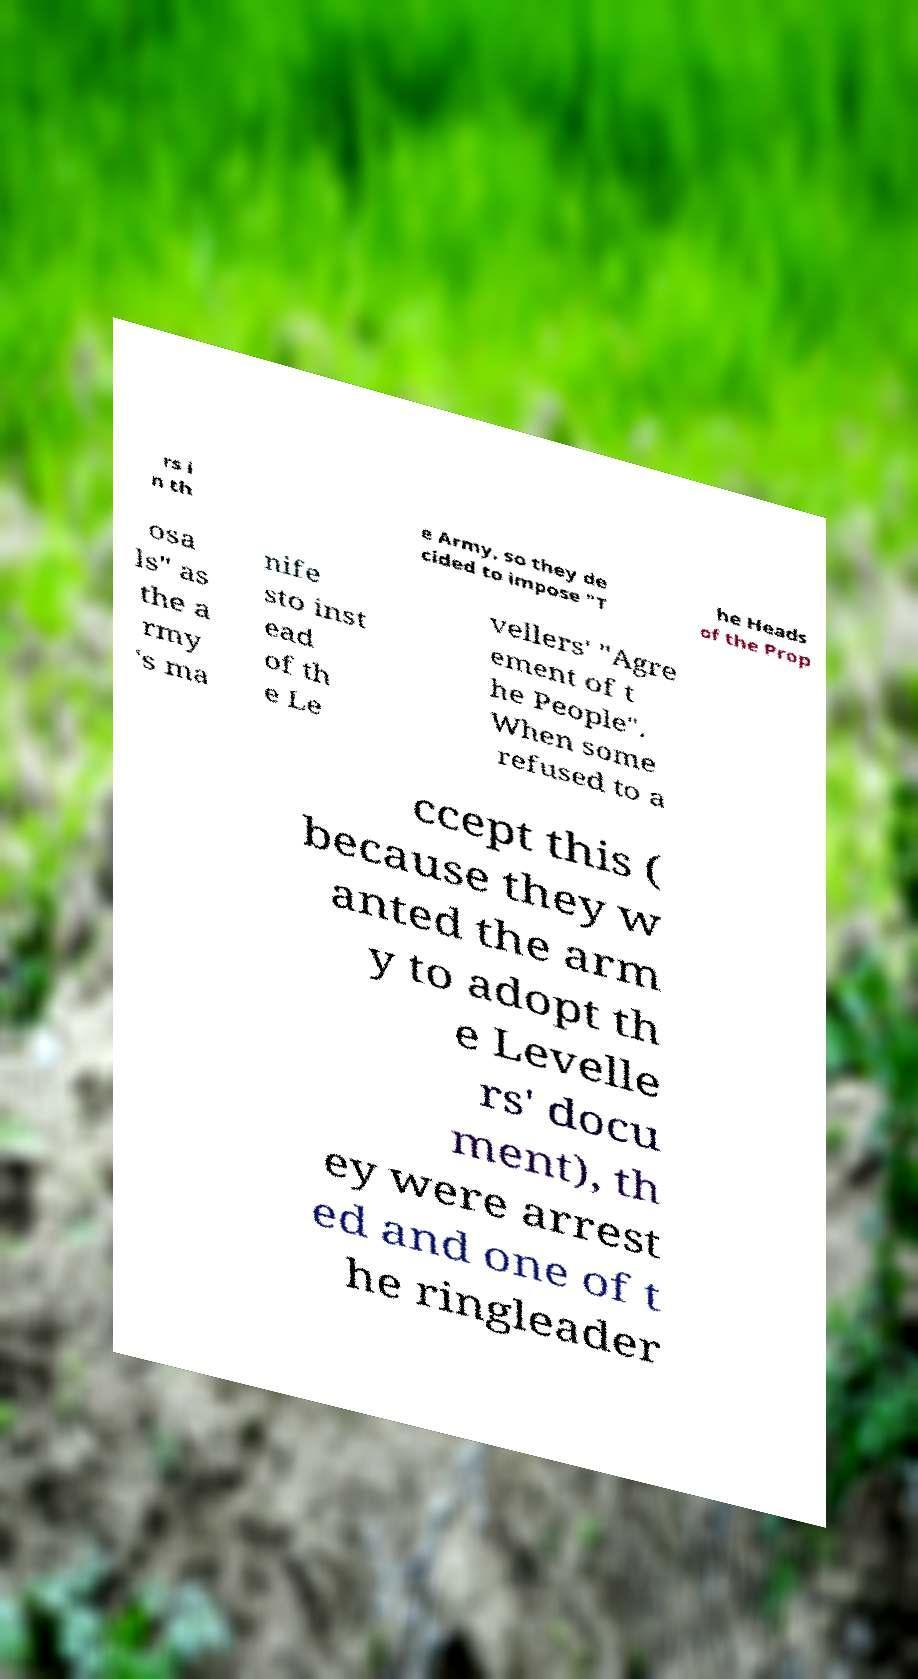Could you assist in decoding the text presented in this image and type it out clearly? rs i n th e Army, so they de cided to impose "T he Heads of the Prop osa ls" as the a rmy 's ma nife sto inst ead of th e Le vellers' "Agre ement of t he People". When some refused to a ccept this ( because they w anted the arm y to adopt th e Levelle rs' docu ment), th ey were arrest ed and one of t he ringleader 